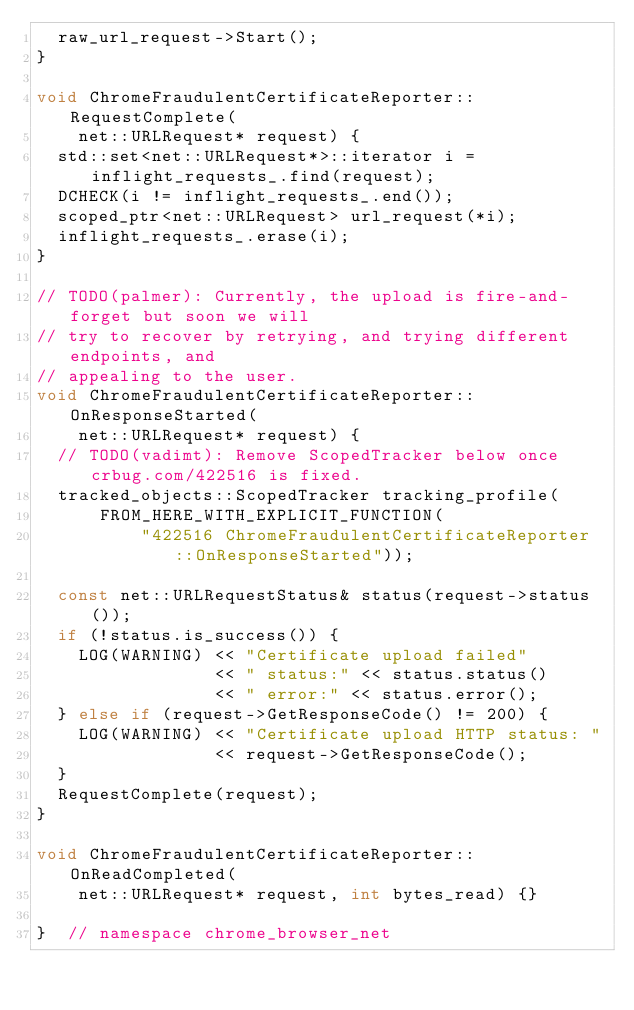Convert code to text. <code><loc_0><loc_0><loc_500><loc_500><_C++_>  raw_url_request->Start();
}

void ChromeFraudulentCertificateReporter::RequestComplete(
    net::URLRequest* request) {
  std::set<net::URLRequest*>::iterator i = inflight_requests_.find(request);
  DCHECK(i != inflight_requests_.end());
  scoped_ptr<net::URLRequest> url_request(*i);
  inflight_requests_.erase(i);
}

// TODO(palmer): Currently, the upload is fire-and-forget but soon we will
// try to recover by retrying, and trying different endpoints, and
// appealing to the user.
void ChromeFraudulentCertificateReporter::OnResponseStarted(
    net::URLRequest* request) {
  // TODO(vadimt): Remove ScopedTracker below once crbug.com/422516 is fixed.
  tracked_objects::ScopedTracker tracking_profile(
      FROM_HERE_WITH_EXPLICIT_FUNCTION(
          "422516 ChromeFraudulentCertificateReporter::OnResponseStarted"));

  const net::URLRequestStatus& status(request->status());
  if (!status.is_success()) {
    LOG(WARNING) << "Certificate upload failed"
                 << " status:" << status.status()
                 << " error:" << status.error();
  } else if (request->GetResponseCode() != 200) {
    LOG(WARNING) << "Certificate upload HTTP status: "
                 << request->GetResponseCode();
  }
  RequestComplete(request);
}

void ChromeFraudulentCertificateReporter::OnReadCompleted(
    net::URLRequest* request, int bytes_read) {}

}  // namespace chrome_browser_net
</code> 